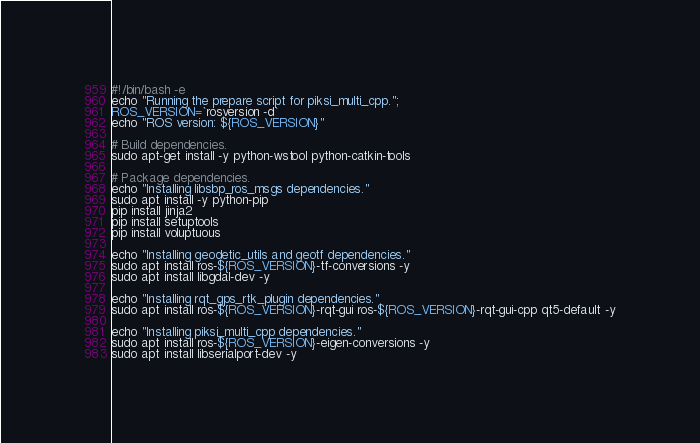<code> <loc_0><loc_0><loc_500><loc_500><_Bash_>#!/bin/bash -e
echo "Running the prepare script for piksi_multi_cpp.";
ROS_VERSION=`rosversion -d`
echo "ROS version: ${ROS_VERSION}"

# Build dependencies.
sudo apt-get install -y python-wstool python-catkin-tools

# Package dependencies.
echo "Installing libsbp_ros_msgs dependencies."
sudo apt install -y python-pip
pip install jinja2
pip install setuptools
pip install voluptuous

echo "Installing geodetic_utils and geotf dependencies."
sudo apt install ros-${ROS_VERSION}-tf-conversions -y
sudo apt install libgdal-dev -y

echo "Installing rqt_gps_rtk_plugin dependencies."
sudo apt install ros-${ROS_VERSION}-rqt-gui ros-${ROS_VERSION}-rqt-gui-cpp qt5-default -y

echo "Installing piksi_multi_cpp dependencies."
sudo apt install ros-${ROS_VERSION}-eigen-conversions -y
sudo apt install libserialport-dev -y</code> 